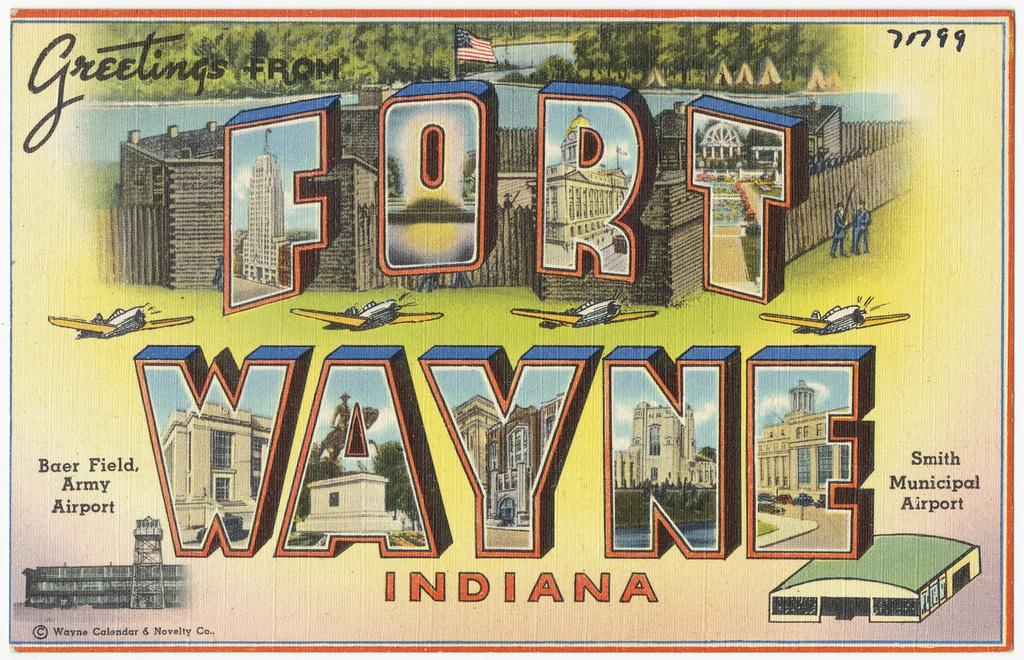<image>
Relay a brief, clear account of the picture shown. a post card for fort wayne indiana usa 